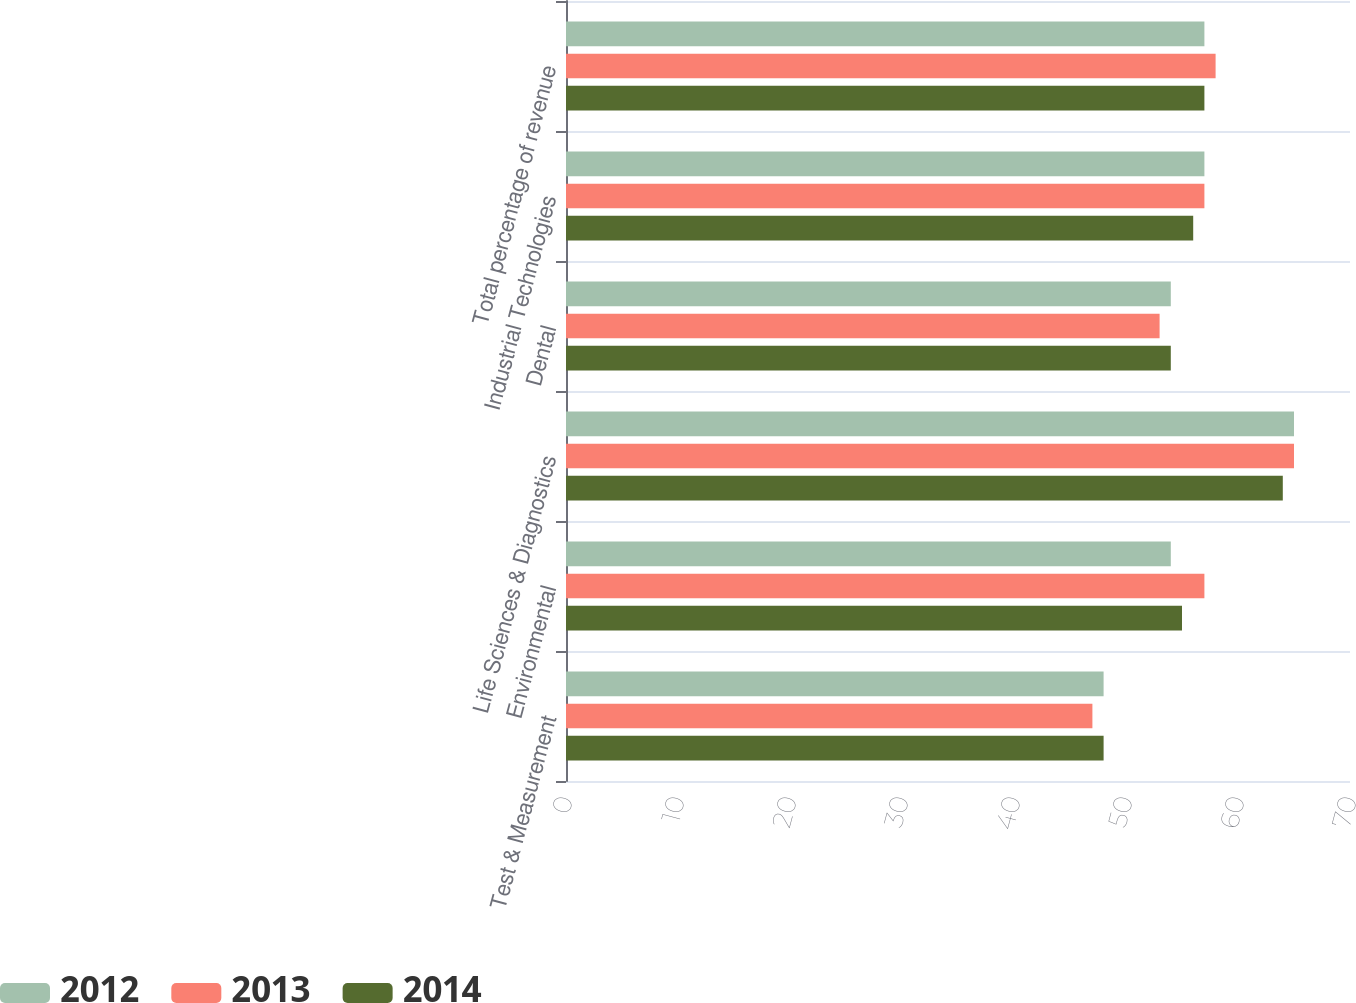Convert chart to OTSL. <chart><loc_0><loc_0><loc_500><loc_500><stacked_bar_chart><ecel><fcel>Test & Measurement<fcel>Environmental<fcel>Life Sciences & Diagnostics<fcel>Dental<fcel>Industrial Technologies<fcel>Total percentage of revenue<nl><fcel>2012<fcel>48<fcel>54<fcel>65<fcel>54<fcel>57<fcel>57<nl><fcel>2013<fcel>47<fcel>57<fcel>65<fcel>53<fcel>57<fcel>58<nl><fcel>2014<fcel>48<fcel>55<fcel>64<fcel>54<fcel>56<fcel>57<nl></chart> 